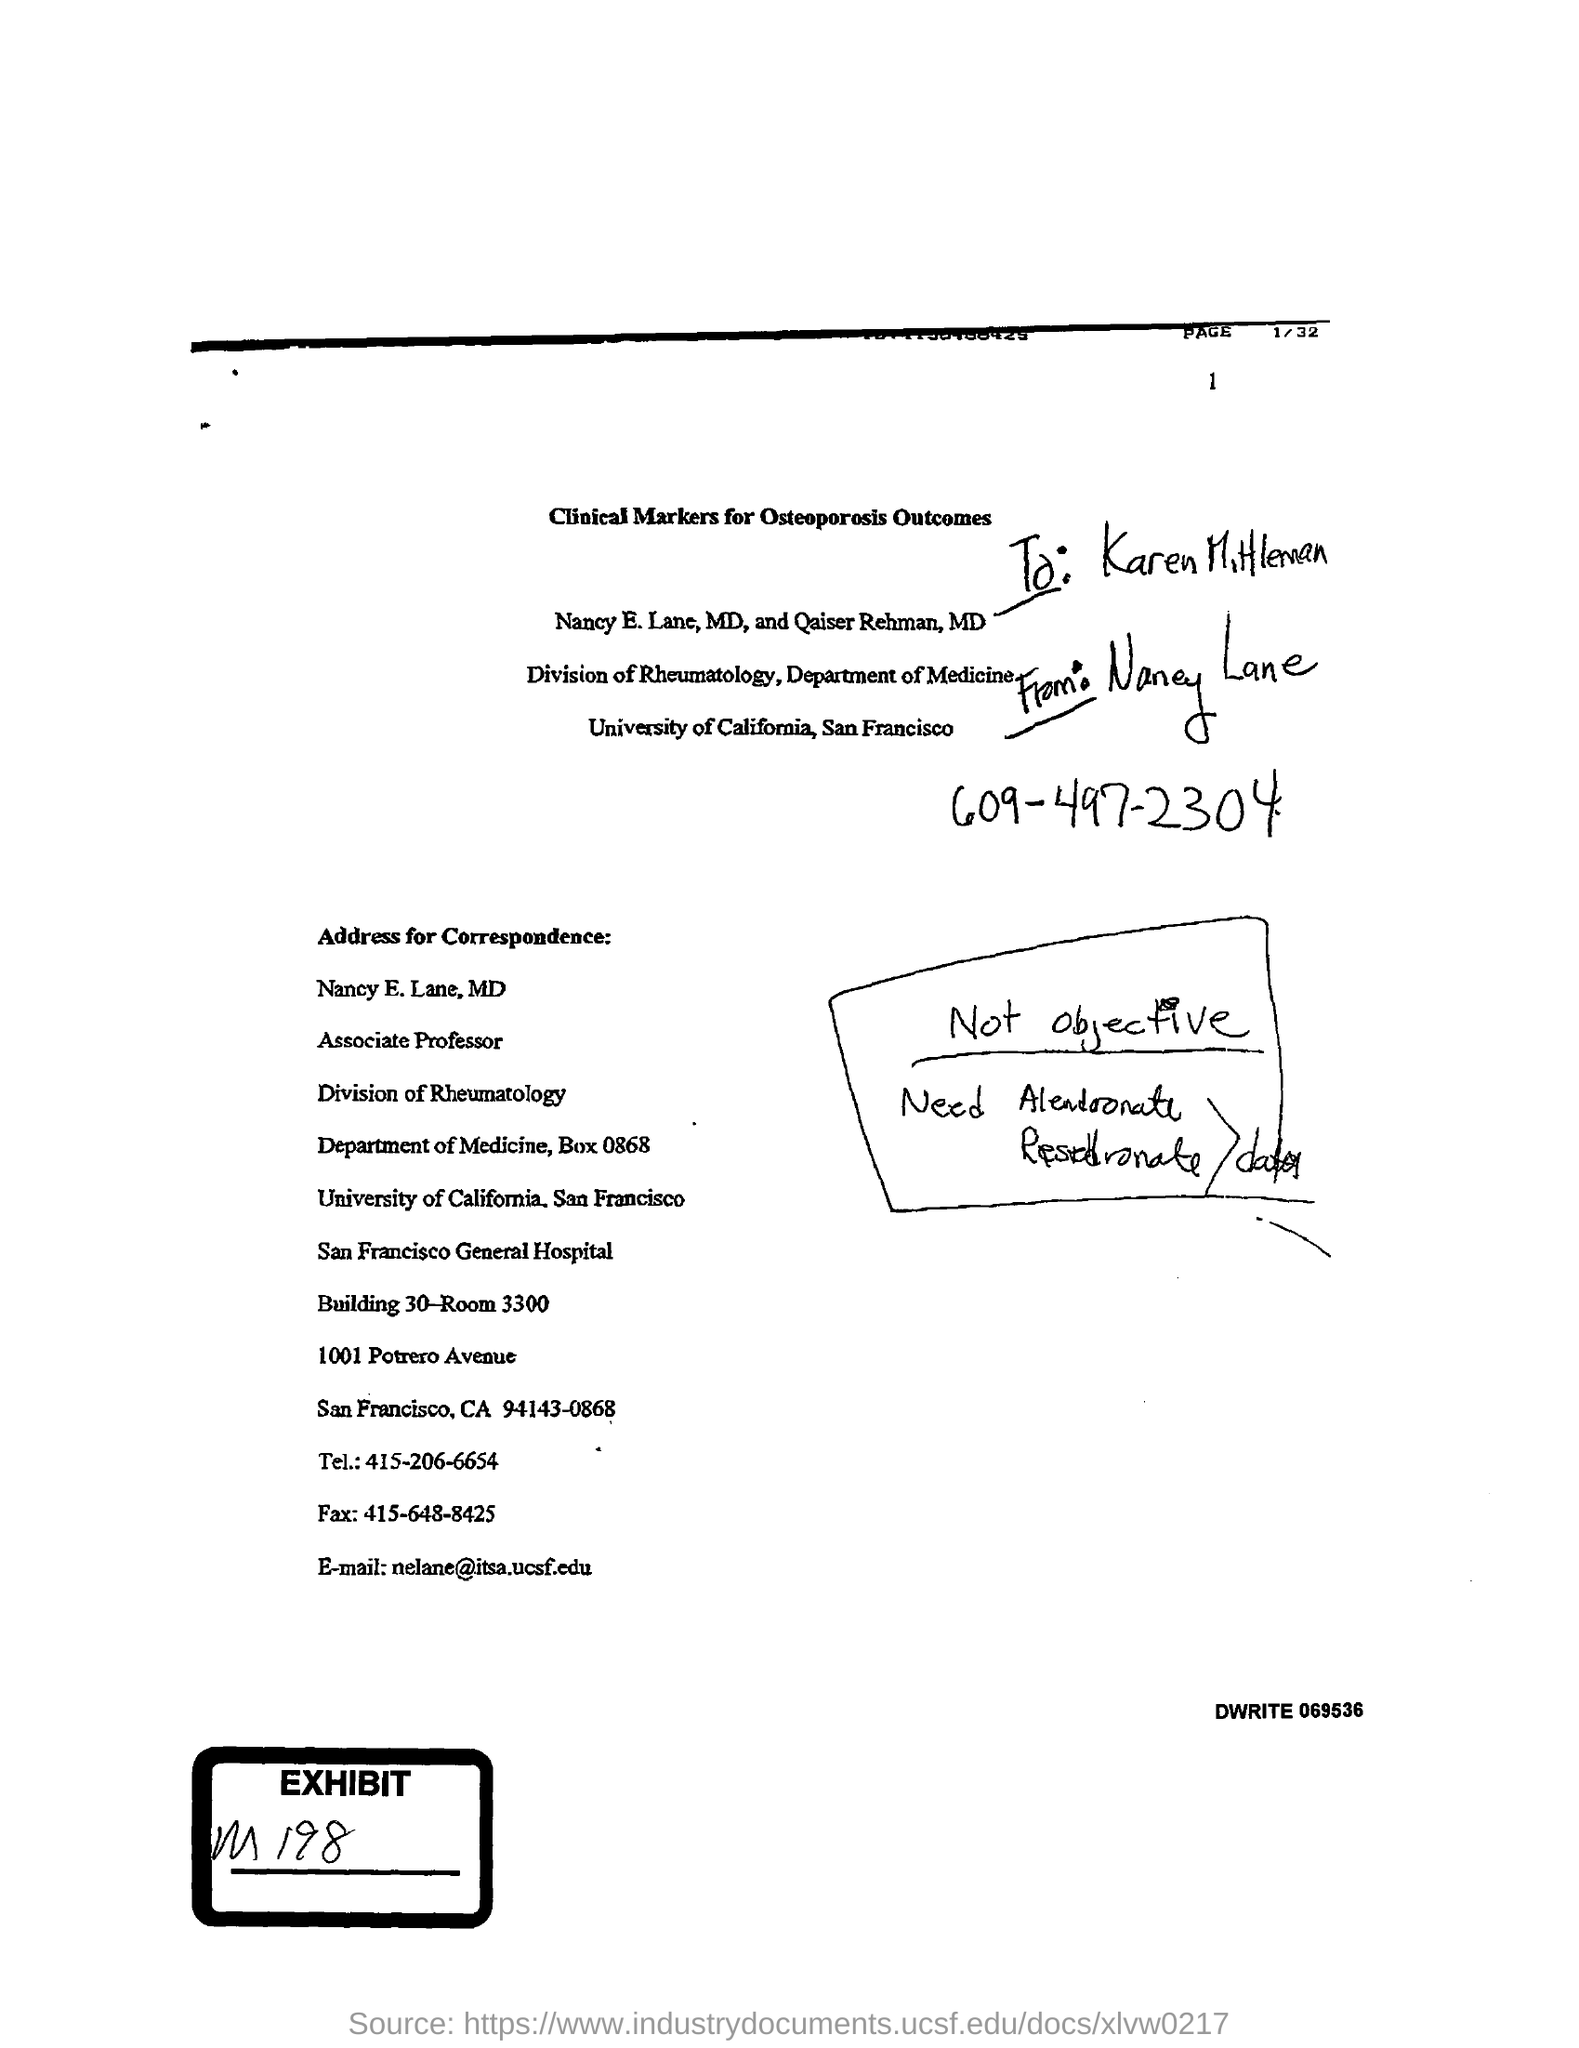Outline some significant characteristics in this image. The fax number mentioned in the letter is 415-648-8425. The telephone number mentioned in the given letter is 415-206-6654. The speaker is asking about the division to which Nancy E. Lane belongs. She belongs to the division of Rheumatology. Nancy E. Lane belongs to the Department of Medicine. 